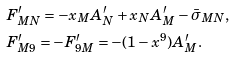<formula> <loc_0><loc_0><loc_500><loc_500>& F ^ { \prime } _ { M N } = - x _ { M } A ^ { \prime } _ { N } + x _ { N } A ^ { \prime } _ { M } - \bar { \sigma } _ { M N } , \\ & F ^ { \prime } _ { M 9 } = - F ^ { \prime } _ { 9 M } = - ( 1 - x ^ { 9 } ) A ^ { \prime } _ { M } .</formula> 